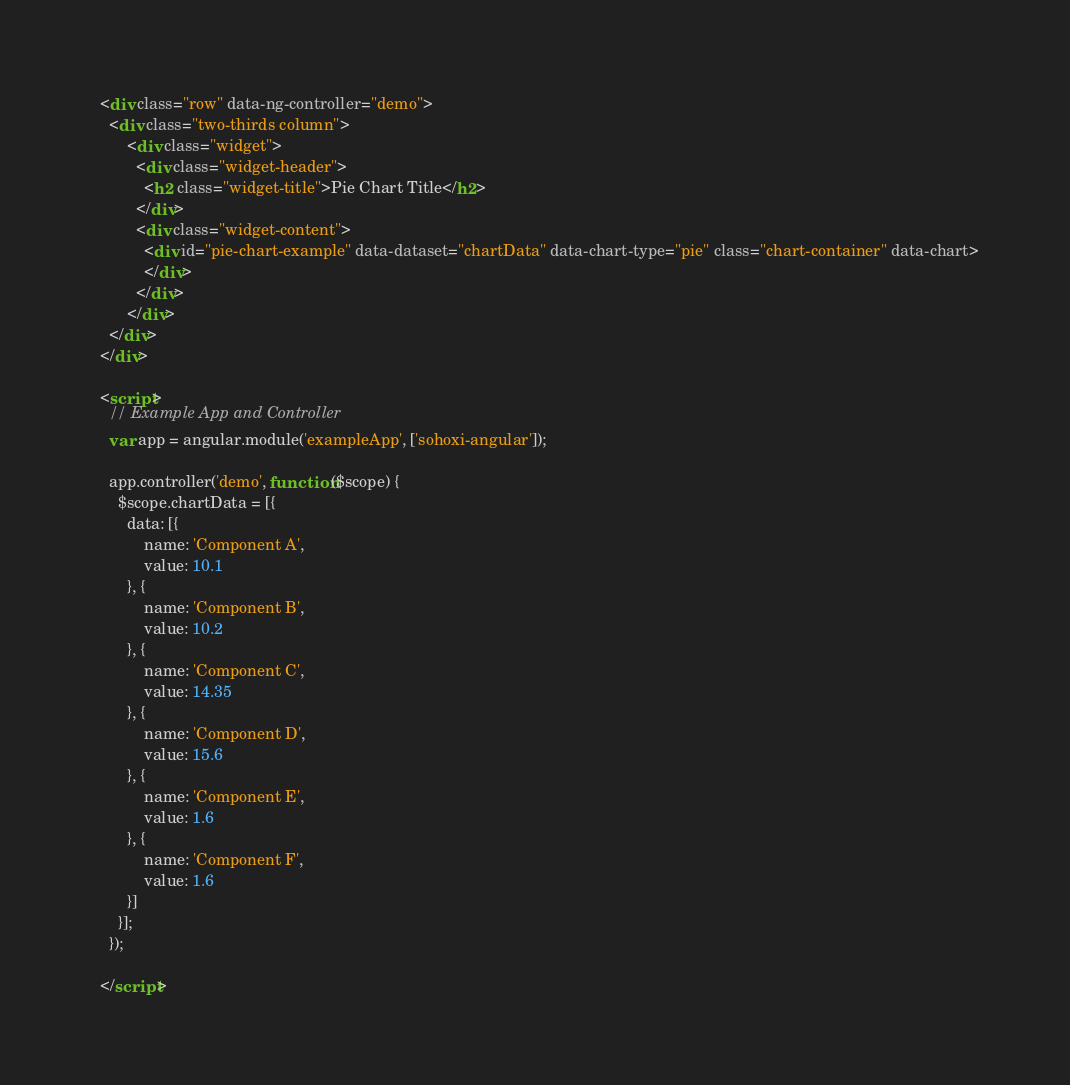Convert code to text. <code><loc_0><loc_0><loc_500><loc_500><_HTML_>
  <div class="row" data-ng-controller="demo">
    <div class="two-thirds column">
        <div class="widget">
          <div class="widget-header">
            <h2 class="widget-title">Pie Chart Title</h2>
          </div>
          <div class="widget-content">
            <div id="pie-chart-example" data-dataset="chartData" data-chart-type="pie" class="chart-container" data-chart>
            </div>
          </div>
        </div>
    </div>
  </div>

  <script>
    // Example App and Controller
    var app = angular.module('exampleApp', ['sohoxi-angular']);

    app.controller('demo', function($scope) {
      $scope.chartData = [{
        data: [{
            name: 'Component A',
            value: 10.1
        }, {
            name: 'Component B',
            value: 10.2
        }, {
            name: 'Component C',
            value: 14.35
        }, {
            name: 'Component D',
            value: 15.6
        }, {
            name: 'Component E',
            value: 1.6
        }, {
            name: 'Component F',
            value: 1.6
        }]
      }];
    });

  </script>
</code> 